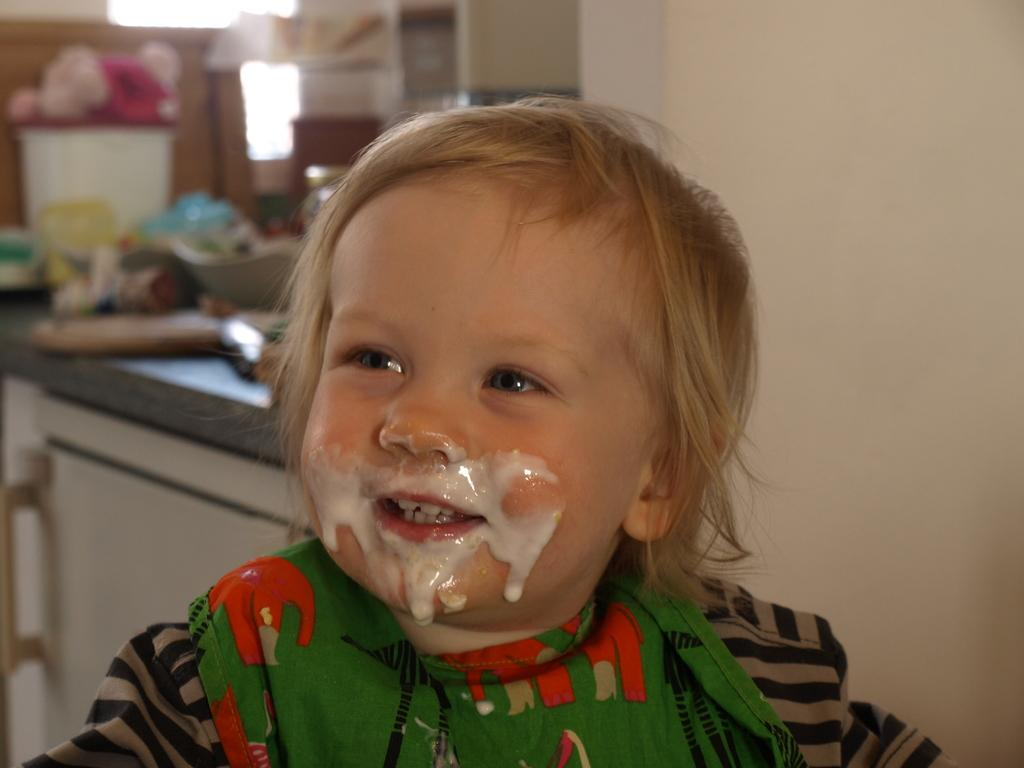What is the main subject in the center of the image? There is a kid in the center of the image. What can be seen in the background of the image? There are objects on a table, a bucket, lights, and a wall in the background. Can you tell me how many balls are being juggled by the kid in the image? There is no information about any balls in the provided facts, so we cannot determine if the kid is juggling any balls in the image. 